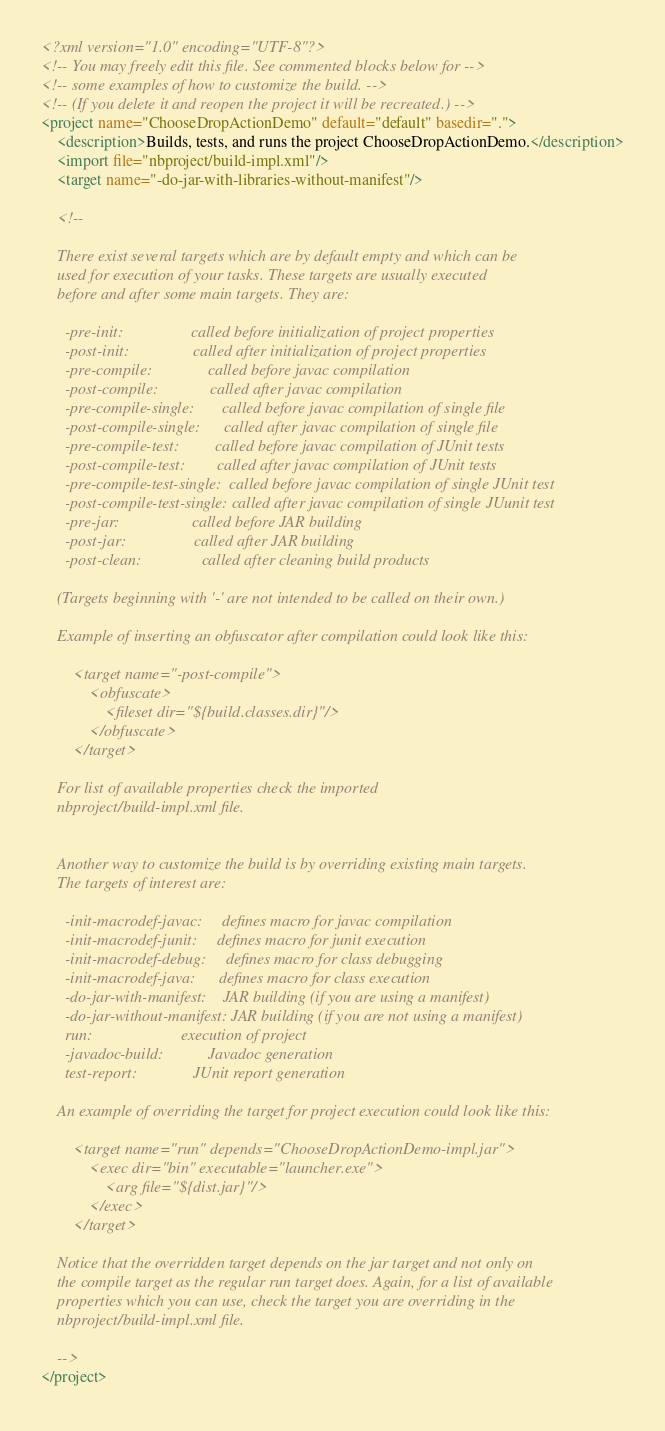<code> <loc_0><loc_0><loc_500><loc_500><_XML_><?xml version="1.0" encoding="UTF-8"?>
<!-- You may freely edit this file. See commented blocks below for -->
<!-- some examples of how to customize the build. -->
<!-- (If you delete it and reopen the project it will be recreated.) -->
<project name="ChooseDropActionDemo" default="default" basedir=".">
    <description>Builds, tests, and runs the project ChooseDropActionDemo.</description>
    <import file="nbproject/build-impl.xml"/>
    <target name="-do-jar-with-libraries-without-manifest"/>

    <!--

    There exist several targets which are by default empty and which can be 
    used for execution of your tasks. These targets are usually executed 
    before and after some main targets. They are: 

      -pre-init:                 called before initialization of project properties
      -post-init:                called after initialization of project properties
      -pre-compile:              called before javac compilation
      -post-compile:             called after javac compilation
      -pre-compile-single:       called before javac compilation of single file
      -post-compile-single:      called after javac compilation of single file
      -pre-compile-test:         called before javac compilation of JUnit tests
      -post-compile-test:        called after javac compilation of JUnit tests
      -pre-compile-test-single:  called before javac compilation of single JUnit test
      -post-compile-test-single: called after javac compilation of single JUunit test
      -pre-jar:                  called before JAR building
      -post-jar:                 called after JAR building
      -post-clean:               called after cleaning build products

    (Targets beginning with '-' are not intended to be called on their own.)

    Example of inserting an obfuscator after compilation could look like this:

        <target name="-post-compile">
            <obfuscate>
                <fileset dir="${build.classes.dir}"/>
            </obfuscate>
        </target>

    For list of available properties check the imported 
    nbproject/build-impl.xml file. 


    Another way to customize the build is by overriding existing main targets.
    The targets of interest are: 

      -init-macrodef-javac:     defines macro for javac compilation
      -init-macrodef-junit:     defines macro for junit execution
      -init-macrodef-debug:     defines macro for class debugging
      -init-macrodef-java:      defines macro for class execution
      -do-jar-with-manifest:    JAR building (if you are using a manifest)
      -do-jar-without-manifest: JAR building (if you are not using a manifest)
      run:                      execution of project 
      -javadoc-build:           Javadoc generation
      test-report:              JUnit report generation

    An example of overriding the target for project execution could look like this:

        <target name="run" depends="ChooseDropActionDemo-impl.jar">
            <exec dir="bin" executable="launcher.exe">
                <arg file="${dist.jar}"/>
            </exec>
        </target>

    Notice that the overridden target depends on the jar target and not only on 
    the compile target as the regular run target does. Again, for a list of available 
    properties which you can use, check the target you are overriding in the
    nbproject/build-impl.xml file. 

    -->
</project>
</code> 